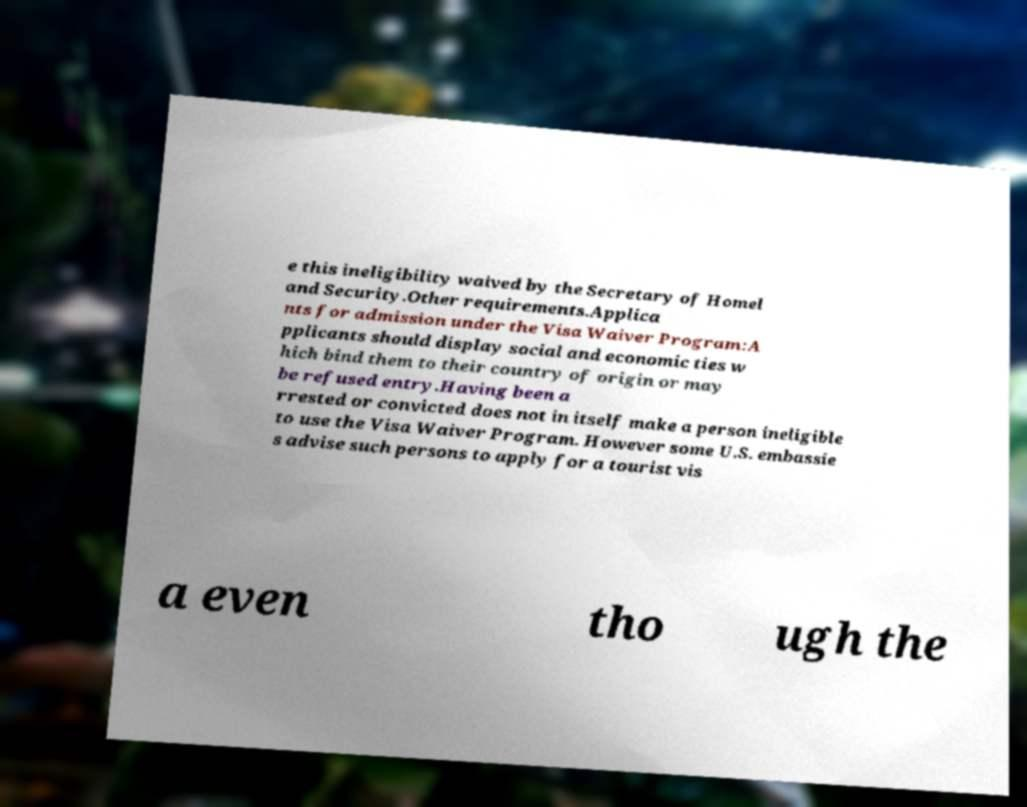Please read and relay the text visible in this image. What does it say? e this ineligibility waived by the Secretary of Homel and Security.Other requirements.Applica nts for admission under the Visa Waiver Program:A pplicants should display social and economic ties w hich bind them to their country of origin or may be refused entry.Having been a rrested or convicted does not in itself make a person ineligible to use the Visa Waiver Program. However some U.S. embassie s advise such persons to apply for a tourist vis a even tho ugh the 